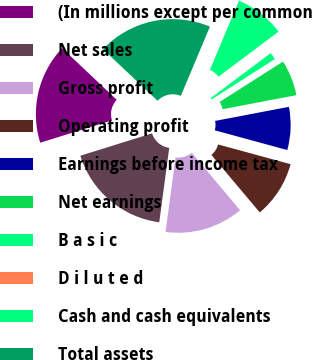Convert chart to OTSL. <chart><loc_0><loc_0><loc_500><loc_500><pie_chart><fcel>(In millions except per common<fcel>Net sales<fcel>Gross profit<fcel>Operating profit<fcel>Earnings before income tax<fcel>Net earnings<fcel>B a s i c<fcel>D i l u t e d<fcel>Cash and cash equivalents<fcel>Total assets<nl><fcel>16.87%<fcel>18.07%<fcel>13.25%<fcel>9.64%<fcel>7.23%<fcel>6.03%<fcel>1.21%<fcel>0.0%<fcel>8.43%<fcel>19.27%<nl></chart> 